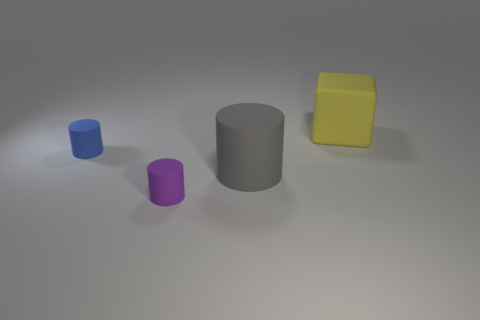There is a large gray object that is the same shape as the purple matte object; what material is it? The large gray object, which shares its cylindrical shape with the smaller purple matte one, appears to be made of a material that suggests a plasticky or metallic texture, given its light reflection and surface characteristics. 